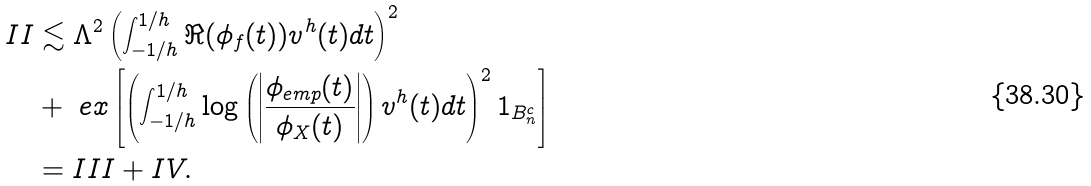Convert formula to latex. <formula><loc_0><loc_0><loc_500><loc_500>I I & \lesssim \Lambda ^ { 2 } \left ( \int _ { - 1 / h } ^ { 1 / h } \Re ( \phi _ { f } ( t ) ) v ^ { h } ( t ) d t \right ) ^ { 2 } \\ & + \ e x \left [ \left ( \int _ { - 1 / h } ^ { 1 / h } \log \left ( \left | \frac { \phi _ { e m p } ( t ) } { \phi _ { X } ( t ) } \right | \right ) v ^ { h } ( t ) d t \right ) ^ { 2 } 1 _ { B _ { n } ^ { c } } \right ] \\ & = I I I + I V .</formula> 